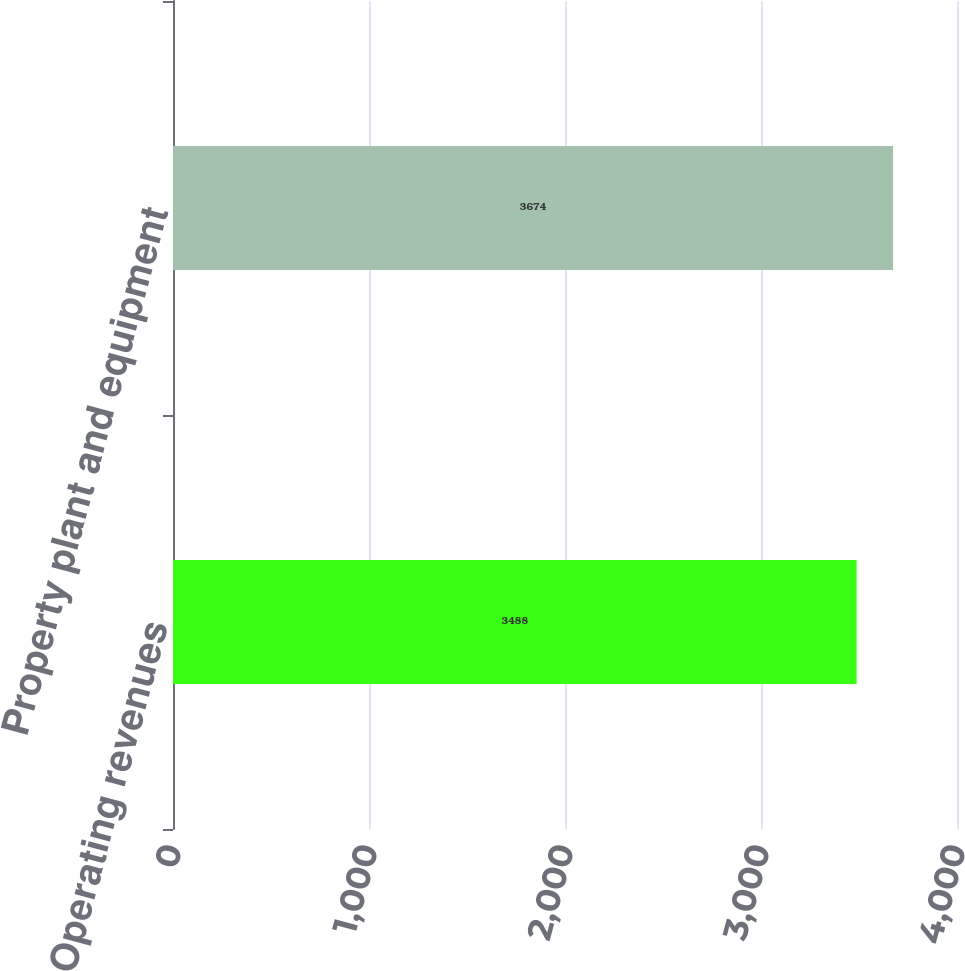Convert chart. <chart><loc_0><loc_0><loc_500><loc_500><bar_chart><fcel>Operating revenues<fcel>Property plant and equipment<nl><fcel>3488<fcel>3674<nl></chart> 